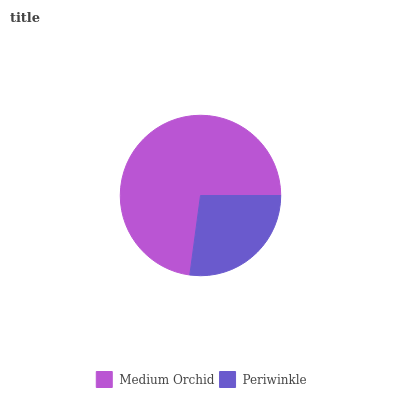Is Periwinkle the minimum?
Answer yes or no. Yes. Is Medium Orchid the maximum?
Answer yes or no. Yes. Is Periwinkle the maximum?
Answer yes or no. No. Is Medium Orchid greater than Periwinkle?
Answer yes or no. Yes. Is Periwinkle less than Medium Orchid?
Answer yes or no. Yes. Is Periwinkle greater than Medium Orchid?
Answer yes or no. No. Is Medium Orchid less than Periwinkle?
Answer yes or no. No. Is Medium Orchid the high median?
Answer yes or no. Yes. Is Periwinkle the low median?
Answer yes or no. Yes. Is Periwinkle the high median?
Answer yes or no. No. Is Medium Orchid the low median?
Answer yes or no. No. 